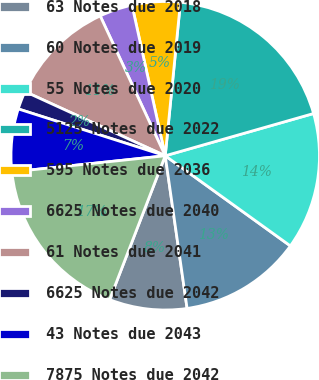Convert chart. <chart><loc_0><loc_0><loc_500><loc_500><pie_chart><fcel>63 Notes due 2018<fcel>60 Notes due 2019<fcel>55 Notes due 2020<fcel>5125 Notes due 2022<fcel>595 Notes due 2036<fcel>6625 Notes due 2040<fcel>61 Notes due 2041<fcel>6625 Notes due 2042<fcel>43 Notes due 2043<fcel>7875 Notes due 2042<nl><fcel>8.13%<fcel>12.8%<fcel>14.35%<fcel>19.01%<fcel>5.03%<fcel>3.47%<fcel>11.24%<fcel>1.92%<fcel>6.58%<fcel>17.46%<nl></chart> 